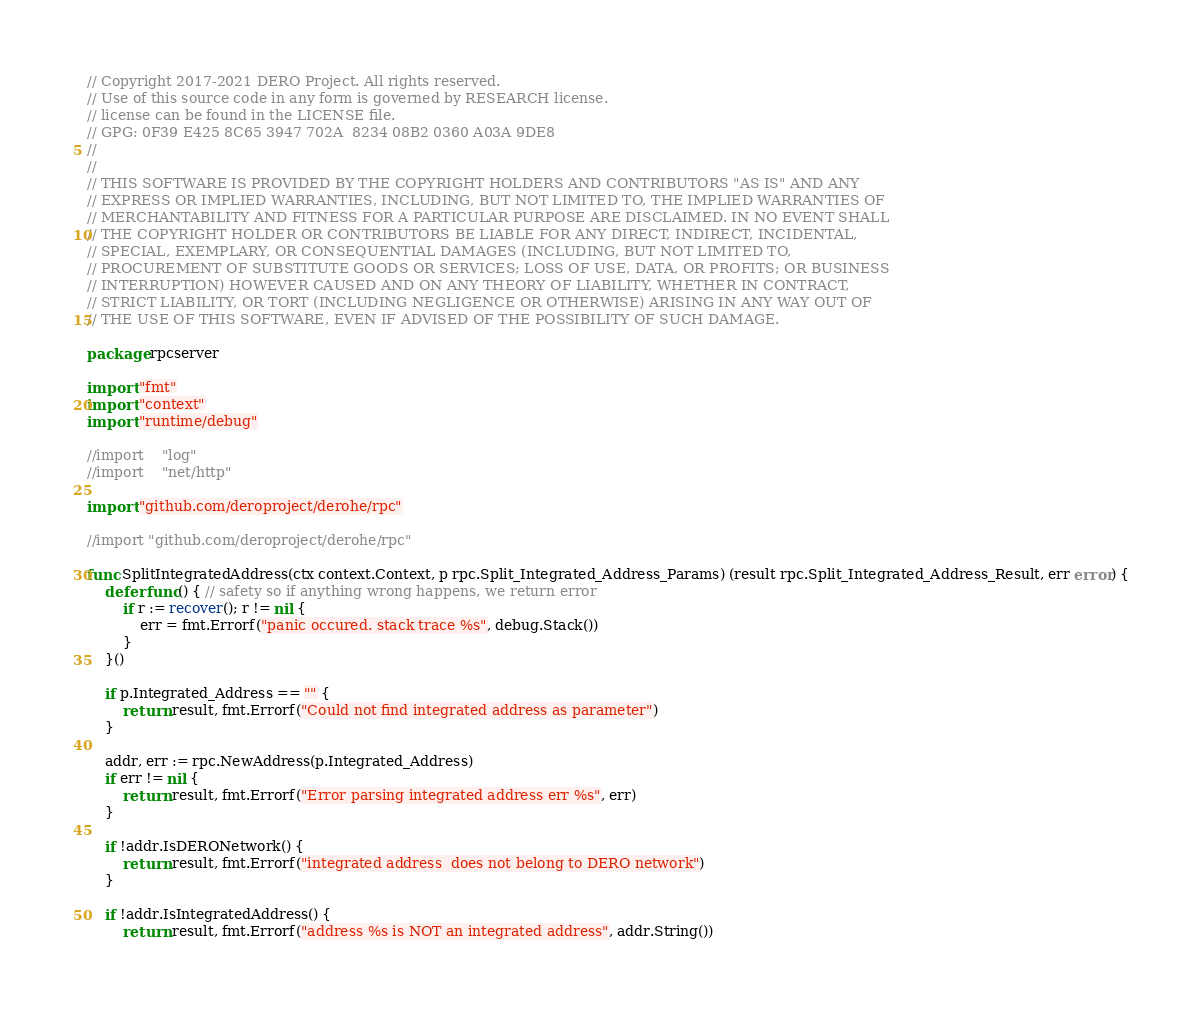Convert code to text. <code><loc_0><loc_0><loc_500><loc_500><_Go_>// Copyright 2017-2021 DERO Project. All rights reserved.
// Use of this source code in any form is governed by RESEARCH license.
// license can be found in the LICENSE file.
// GPG: 0F39 E425 8C65 3947 702A  8234 08B2 0360 A03A 9DE8
//
//
// THIS SOFTWARE IS PROVIDED BY THE COPYRIGHT HOLDERS AND CONTRIBUTORS "AS IS" AND ANY
// EXPRESS OR IMPLIED WARRANTIES, INCLUDING, BUT NOT LIMITED TO, THE IMPLIED WARRANTIES OF
// MERCHANTABILITY AND FITNESS FOR A PARTICULAR PURPOSE ARE DISCLAIMED. IN NO EVENT SHALL
// THE COPYRIGHT HOLDER OR CONTRIBUTORS BE LIABLE FOR ANY DIRECT, INDIRECT, INCIDENTAL,
// SPECIAL, EXEMPLARY, OR CONSEQUENTIAL DAMAGES (INCLUDING, BUT NOT LIMITED TO,
// PROCUREMENT OF SUBSTITUTE GOODS OR SERVICES; LOSS OF USE, DATA, OR PROFITS; OR BUSINESS
// INTERRUPTION) HOWEVER CAUSED AND ON ANY THEORY OF LIABILITY, WHETHER IN CONTRACT,
// STRICT LIABILITY, OR TORT (INCLUDING NEGLIGENCE OR OTHERWISE) ARISING IN ANY WAY OUT OF
// THE USE OF THIS SOFTWARE, EVEN IF ADVISED OF THE POSSIBILITY OF SUCH DAMAGE.

package rpcserver

import "fmt"
import "context"
import "runtime/debug"

//import	"log"
//import 	"net/http"

import "github.com/deroproject/derohe/rpc"

//import "github.com/deroproject/derohe/rpc"

func SplitIntegratedAddress(ctx context.Context, p rpc.Split_Integrated_Address_Params) (result rpc.Split_Integrated_Address_Result, err error) {
	defer func() { // safety so if anything wrong happens, we return error
		if r := recover(); r != nil {
			err = fmt.Errorf("panic occured. stack trace %s", debug.Stack())
		}
	}()

	if p.Integrated_Address == "" {
		return result, fmt.Errorf("Could not find integrated address as parameter")
	}

	addr, err := rpc.NewAddress(p.Integrated_Address)
	if err != nil {
		return result, fmt.Errorf("Error parsing integrated address err %s", err)
	}

	if !addr.IsDERONetwork() {
		return result, fmt.Errorf("integrated address  does not belong to DERO network")
	}

	if !addr.IsIntegratedAddress() {
		return result, fmt.Errorf("address %s is NOT an integrated address", addr.String())</code> 